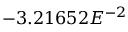Convert formula to latex. <formula><loc_0><loc_0><loc_500><loc_500>- 3 . 2 1 6 5 2 E ^ { - 2 }</formula> 